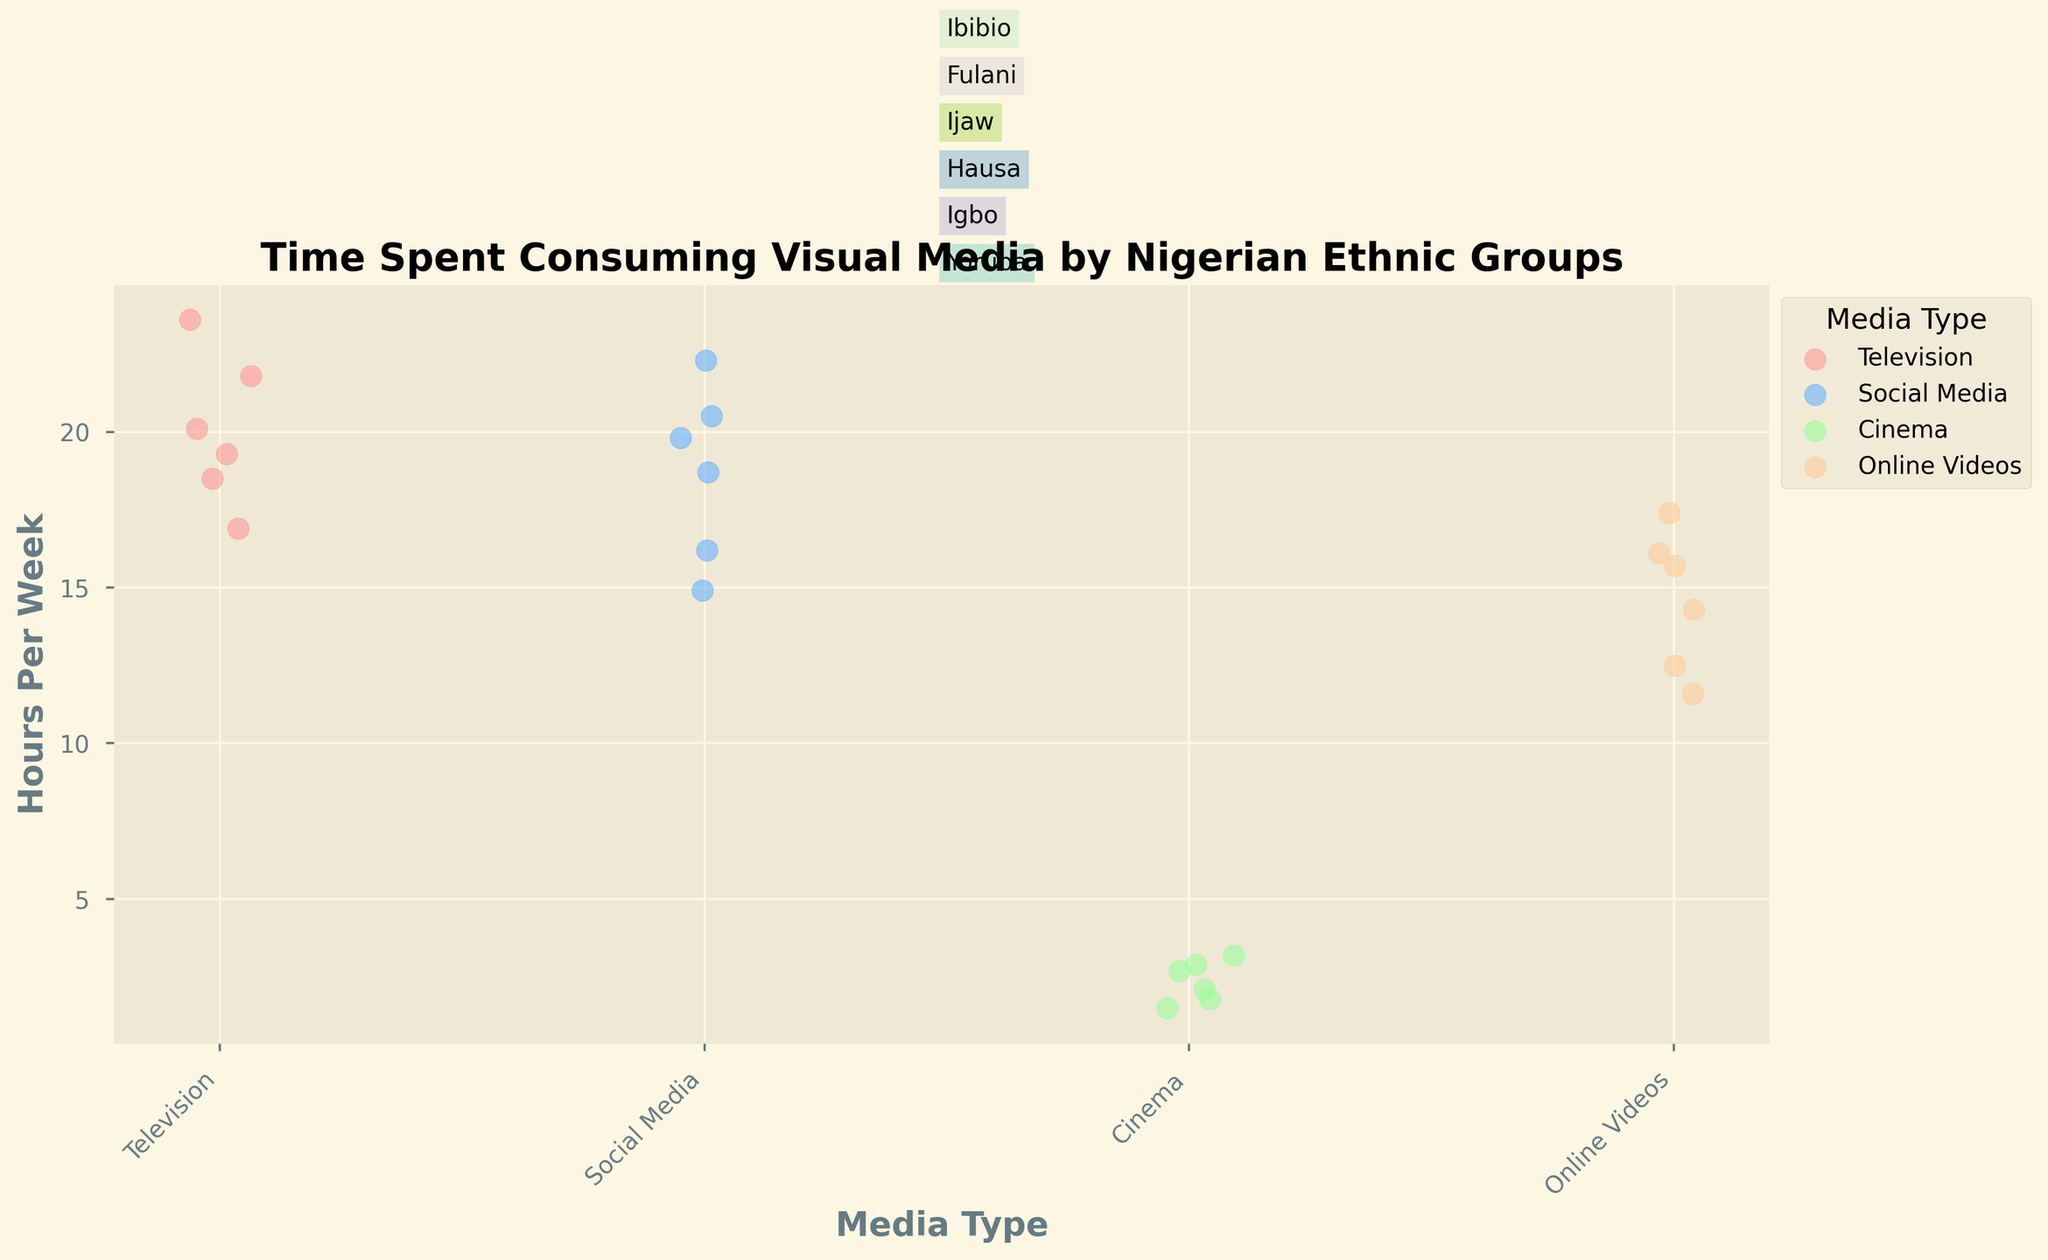Which ethnic group spends the most time watching television per week? To identify this, locate the strip plot for "Television" and observe which ethnic group has the highest point along the y-axis. The Hausa group spends the most time, around 23.6 hours per week.
Answer: Hausa What is the title of the figure? The title is located at the top of the plot, intended to summarize the data visualization.
Answer: Time Spent Consuming Visual Media by Nigerian Ethnic Groups How much time, on average, do the Yoruba and Igbo ethnic groups spend consuming social media per week? Sum the weekly hours spent on social media by Yoruba (22.3 hours) and Igbo (19.8 hours), then divide by 2 to find the average. (22.3 + 19.8) / 2 = 21.05 hours per week.
Answer: 21.05 hours Which media type receives the least amount of time from the Fulani group? Look at the strip plot points for the Fulani ethnic group across all media types and identify the lowest value. Cinema has the least amount of time, 1.5 hours per week.
Answer: Cinema Compare the time spent on online videos by the Hausa and Ijaw ethnic groups. Which group spends more time? Check the strip plot points for online videos for the Hausa (12.5 hours) and Ijaw (14.3 hours) groups; the Ijaw group spends more time.
Answer: Ijaw What is the range of hours per week spent on social media across all ethnic groups? Determine the minimum and maximum values for social media usage from the strip plot. The range is the difference between these values: 22.3 (Yoruba) - 14.9 (Fulani) = 7.4 hours.
Answer: 7.4 hours What media type has the most scattered distribution in hours per week among all ethnic groups? Compare the spread of points in each strip for the different media types. Social media has the most scattered distribution as it shows widely spread points across the y-axis.
Answer: Social Media Is there any media type that one ethnic group does not engage with at all? Review the plot points for each ethnic group across all media types to see if any point is missing. All media types have engagement from each ethnic group, so there are no gaps.
Answer: No Roughly, how many hours per week do ethnic groups spend watching cinema in aggregate? Add up the hours per week spent watching cinema across all the ethnic groups: 3.2 (Yoruba) + 2.9 (Igbo) + 1.8 (Hausa) + 2.1 (Ijaw) + 1.5 (Fulani) + 2.7 (Ibibio) = 14.2 hours per week in total.
Answer: 14.2 hours 